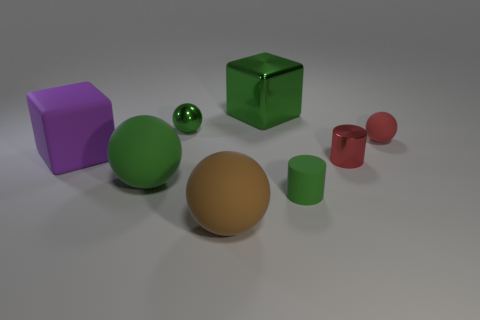What is the shape of the brown rubber thing?
Provide a succinct answer. Sphere. What is the shape of the green rubber thing that is the same size as the brown rubber ball?
Your response must be concise. Sphere. What number of other objects are there of the same color as the small matte ball?
Your answer should be very brief. 1. Is the shape of the tiny metallic object that is to the left of the big green metallic block the same as the tiny green thing that is right of the large shiny block?
Provide a succinct answer. No. How many objects are either big matte things right of the purple object or blocks on the right side of the small green metallic sphere?
Offer a very short reply. 3. What number of other objects are the same material as the green cylinder?
Offer a terse response. 4. Are the large object that is behind the purple object and the small green sphere made of the same material?
Offer a very short reply. Yes. Is the number of tiny green balls that are in front of the green matte ball greater than the number of green shiny blocks behind the purple rubber cube?
Keep it short and to the point. No. What number of things are objects that are in front of the tiny red metal cylinder or large matte cubes?
Make the answer very short. 4. The tiny thing that is the same material as the red sphere is what shape?
Provide a succinct answer. Cylinder. 